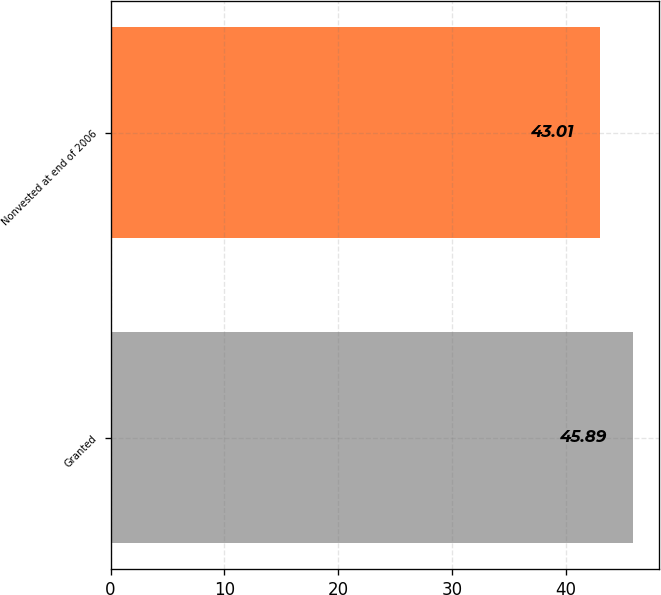Convert chart. <chart><loc_0><loc_0><loc_500><loc_500><bar_chart><fcel>Granted<fcel>Nonvested at end of 2006<nl><fcel>45.89<fcel>43.01<nl></chart> 